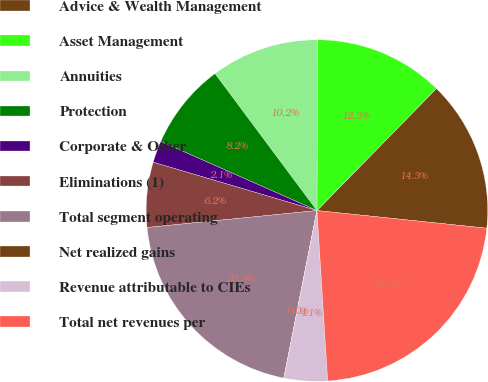Convert chart. <chart><loc_0><loc_0><loc_500><loc_500><pie_chart><fcel>Advice & Wealth Management<fcel>Asset Management<fcel>Annuities<fcel>Protection<fcel>Corporate & Other<fcel>Eliminations (1)<fcel>Total segment operating<fcel>Net realized gains<fcel>Revenue attributable to CIEs<fcel>Total net revenues per<nl><fcel>14.32%<fcel>12.28%<fcel>10.23%<fcel>8.19%<fcel>2.06%<fcel>6.15%<fcel>20.31%<fcel>0.01%<fcel>4.1%<fcel>22.35%<nl></chart> 